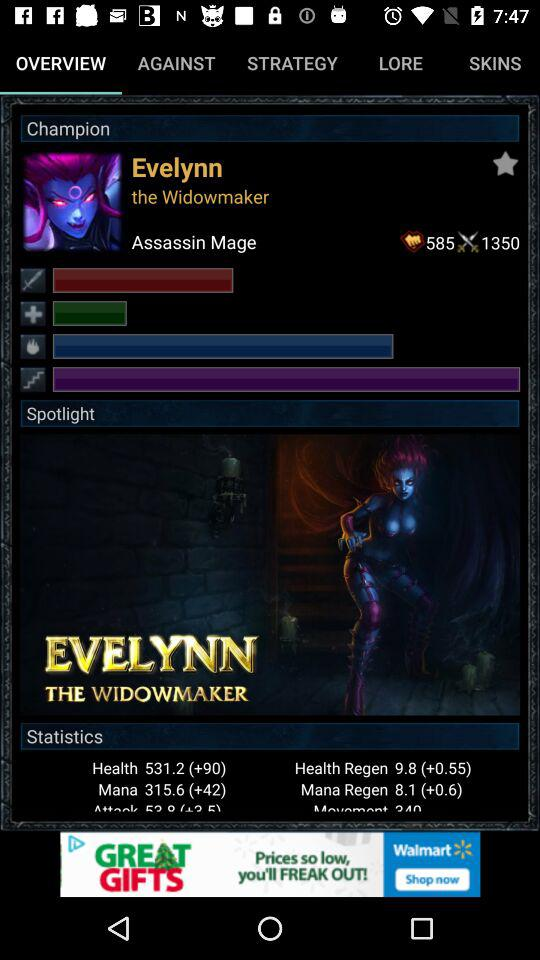What are the statistics for "Health Regen"? The statistics are 9.8 (+0.55). 